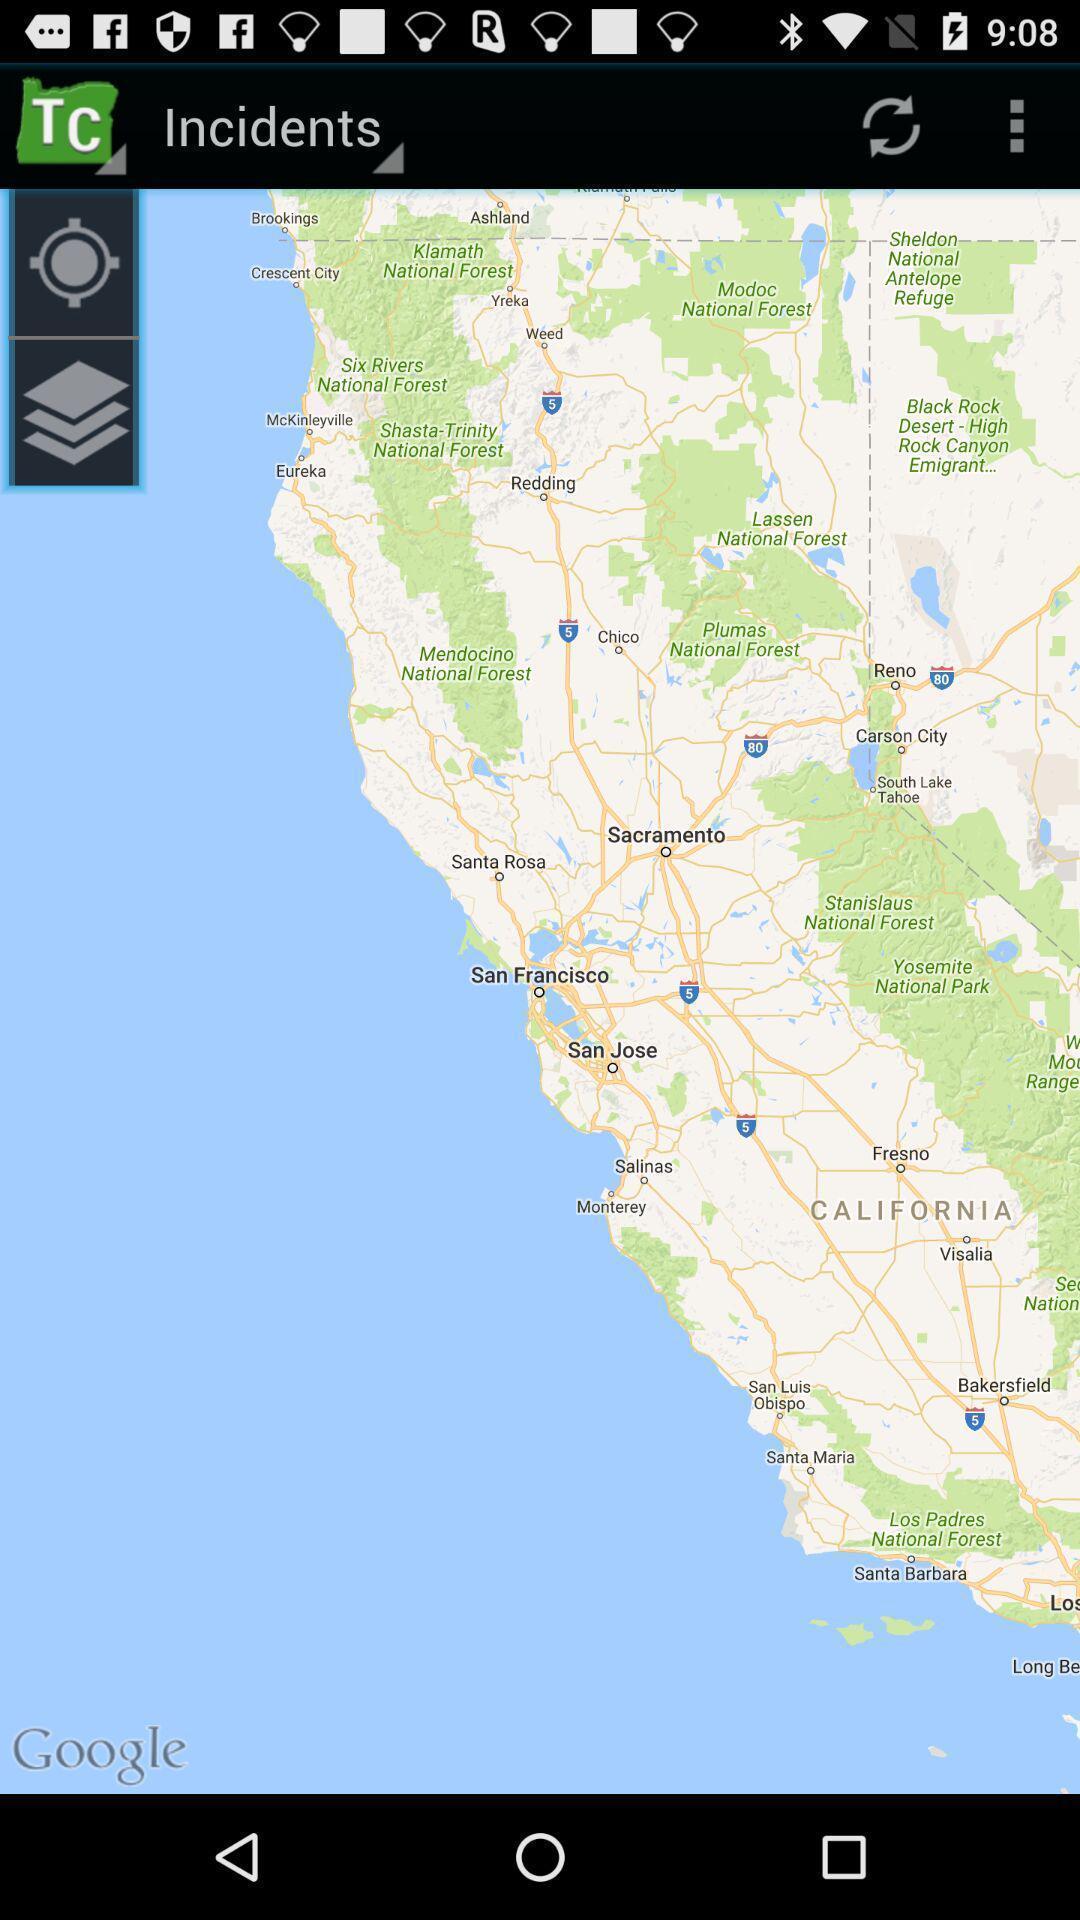Explain what's happening in this screen capture. Settings in incidents page of locations. 